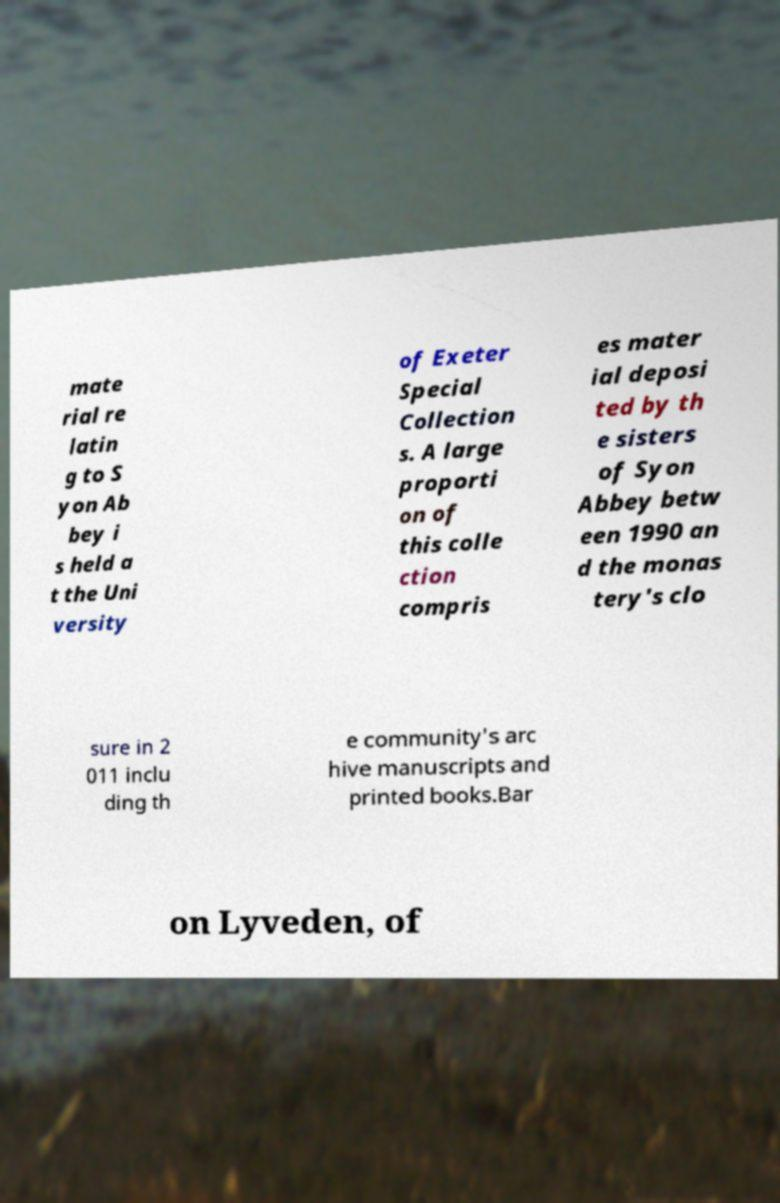Could you extract and type out the text from this image? mate rial re latin g to S yon Ab bey i s held a t the Uni versity of Exeter Special Collection s. A large proporti on of this colle ction compris es mater ial deposi ted by th e sisters of Syon Abbey betw een 1990 an d the monas tery's clo sure in 2 011 inclu ding th e community's arc hive manuscripts and printed books.Bar on Lyveden, of 